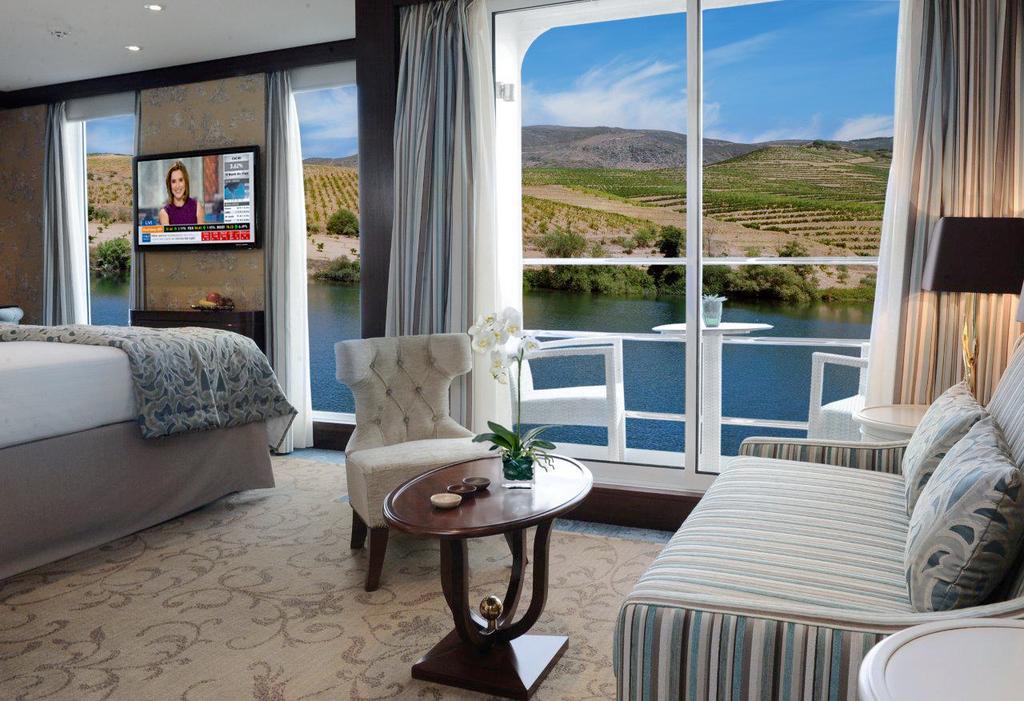Could you give a brief overview of what you see in this image? In the image there is a bed with a blanket, chair, table with flower vase, sofa with pillows, table with lamp and there are glass doors with curtains. Outside the glass door there is a table and there are chairs. In the background there is water, trees with hills and sky with clouds. 